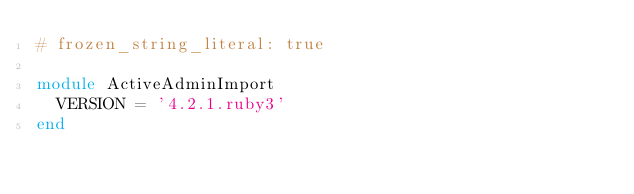<code> <loc_0><loc_0><loc_500><loc_500><_Ruby_># frozen_string_literal: true

module ActiveAdminImport
  VERSION = '4.2.1.ruby3'
end
</code> 